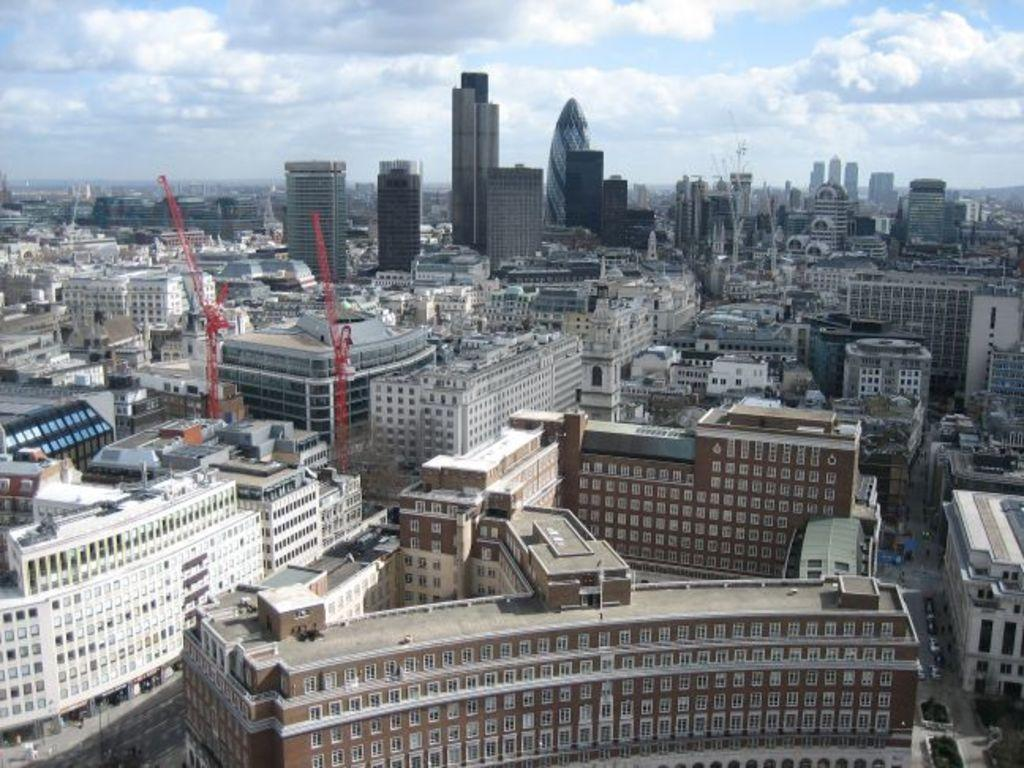What structures can be seen in the image? There are buildings in the image. What part of the natural environment is visible in the image? The sky is visible in the background of the image. What type of stamp can be seen on the buildings in the image? There is no stamp present on the buildings in the image. How many clocks are visible on the buildings in the image? There is no information about clocks on the buildings in the image. 